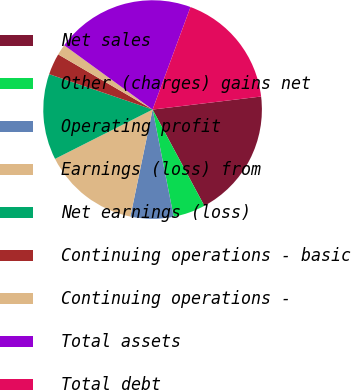<chart> <loc_0><loc_0><loc_500><loc_500><pie_chart><fcel>Net sales<fcel>Other (charges) gains net<fcel>Operating profit<fcel>Earnings (loss) from<fcel>Net earnings (loss)<fcel>Continuing operations - basic<fcel>Continuing operations -<fcel>Total assets<fcel>Total debt<nl><fcel>19.05%<fcel>4.76%<fcel>6.35%<fcel>14.29%<fcel>12.7%<fcel>3.17%<fcel>1.59%<fcel>20.63%<fcel>17.46%<nl></chart> 